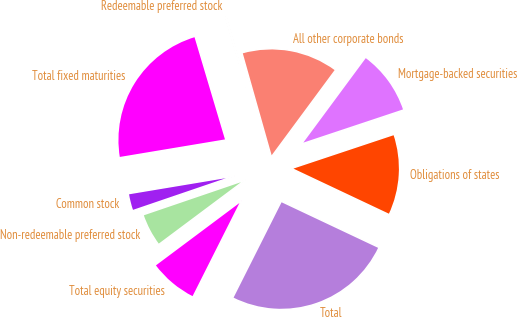Convert chart. <chart><loc_0><loc_0><loc_500><loc_500><pie_chart><fcel>Obligations of states<fcel>Mortgage-backed securities<fcel>All other corporate bonds<fcel>Redeemable preferred stock<fcel>Total fixed maturities<fcel>Common stock<fcel>Non-redeemable preferred stock<fcel>Total equity securities<fcel>Total<nl><fcel>12.14%<fcel>9.75%<fcel>14.52%<fcel>0.22%<fcel>23.02%<fcel>2.6%<fcel>4.98%<fcel>7.37%<fcel>25.4%<nl></chart> 